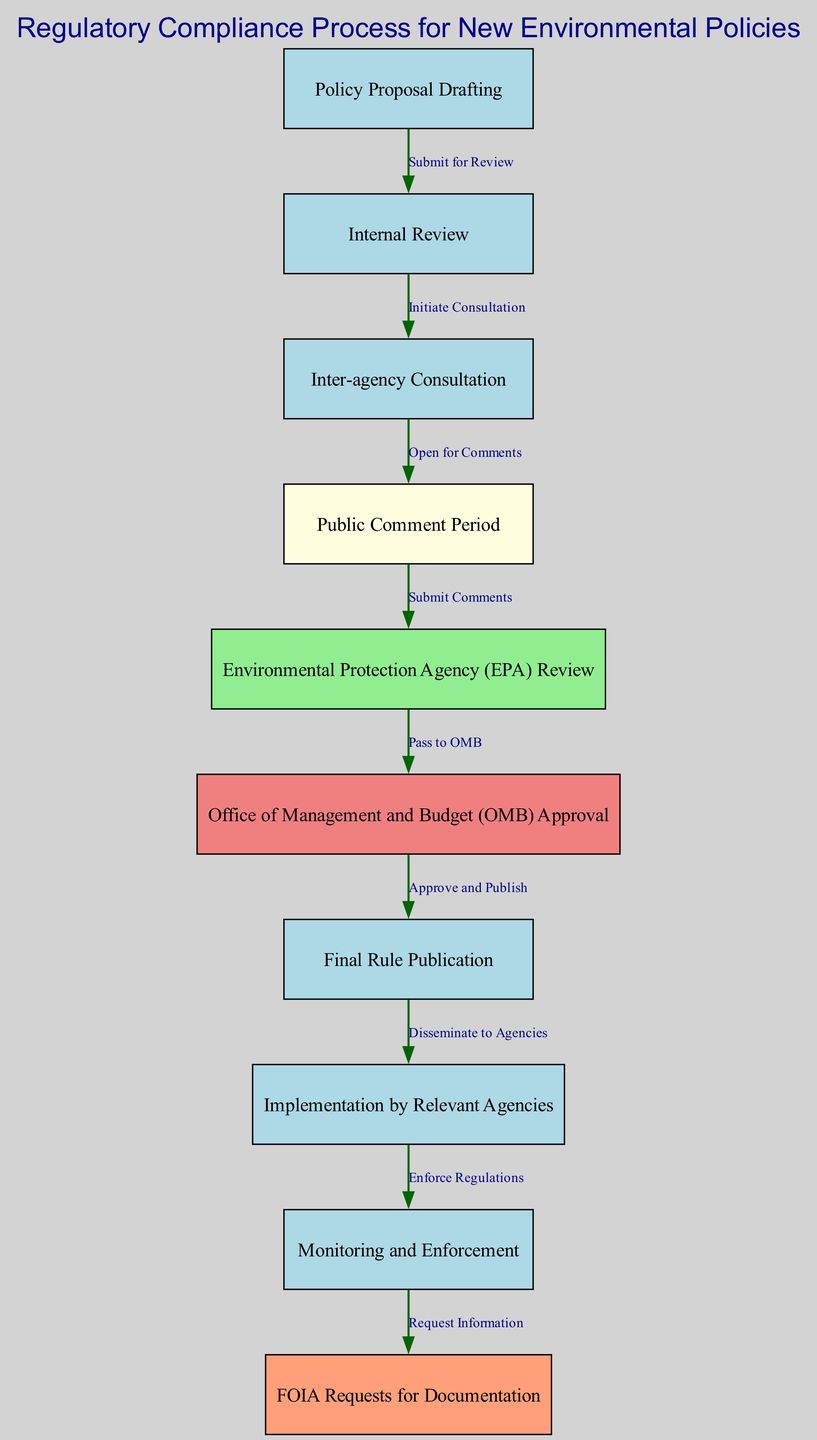What is the first step in the regulatory compliance process? The first step is "Policy Proposal Drafting," as indicated by the node at the starting position of the diagram.
Answer: Policy Proposal Drafting How many nodes are present in the diagram? Counting all unique nodes listed in the diagram, there are a total of ten nodes that represent different steps.
Answer: 10 Which agencies review the policy after the Public Comment Period? After the Public Comment Period, the policy is sent for "Environmental Protection Agency (EPA) Review," as shown in the edges flowing from node 4 to node 5.
Answer: Environmental Protection Agency (EPA) What follows after the OMB Approval? The step that immediately follows "Office of Management and Budget (OMB) Approval," which is node 6, is "Final Rule Publication," represented by node 7 in the diagram.
Answer: Final Rule Publication What is the relationship between Internal Review and Inter-agency Consultation? The relationship is established by the edge labeled "Initiate Consultation" that connects node 2 ("Internal Review") to node 3 ("Inter-agency Consultation").
Answer: Initiate Consultation How many steps involve public interaction? There are two steps that involve public interaction: "Public Comment Period" and "FOIA Requests for Documentation," represented by nodes 4 and 10, respectively.
Answer: 2 What is the ultimate goal after the policy is enforced? The ultimate goal, represented by the final step in the diagram, is "Monitoring and Enforcement," where compliance with the regulations is verified.
Answer: Monitoring and Enforcement Which step comes before the Environmental Protection Agency (EPA) Review? The step that comes before the "Environmental Protection Agency (EPA) Review," indicated by node 5, is the "Public Comment Period," represented by node 4.
Answer: Public Comment Period What action is taken after the Final Rule Publication? The action taken after the "Final Rule Publication" is "Implementation by Relevant Agencies," which follows node 7.
Answer: Implementation by Relevant Agencies 